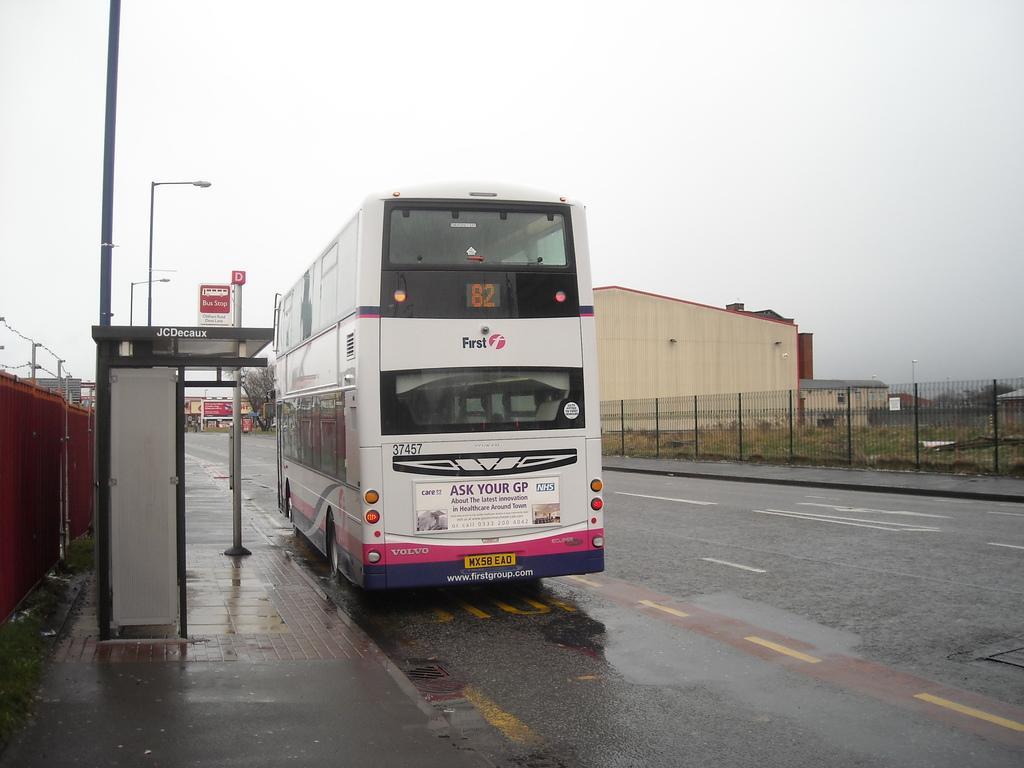Please provide a concise description of this image. The image is taken outside a city. In the foreground of the picture there is a bus stop and a bus on the road. In the middle of the picture we can see trees, building, fencing and field. On the left there are street lights. At the top it is sky. 